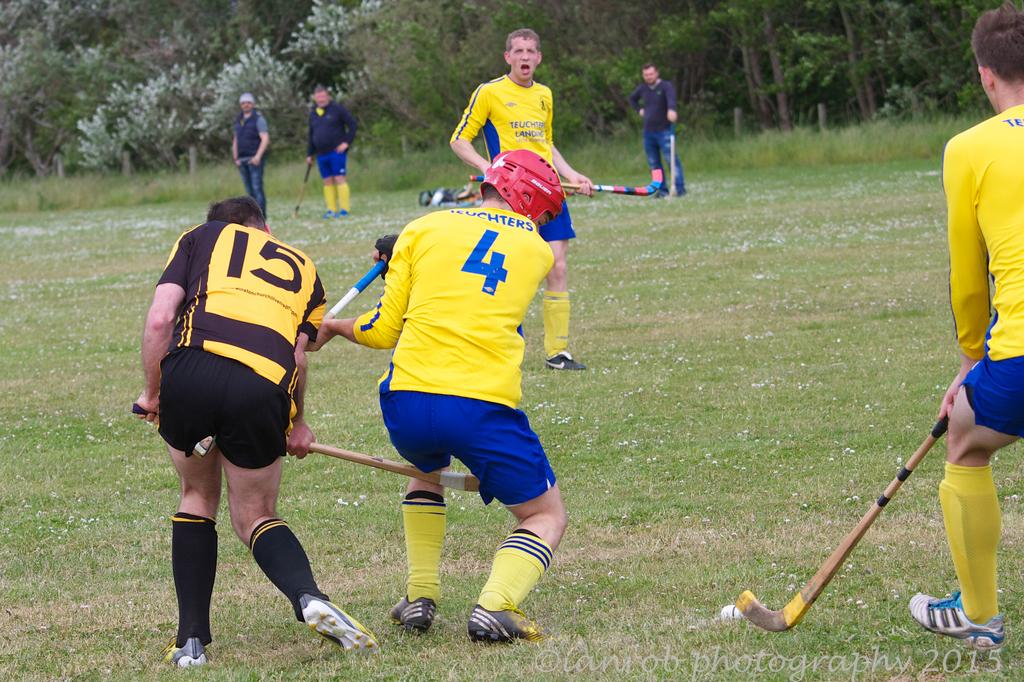What is the number of the player that has black shorts on?
Ensure brevity in your answer.  15. What is the number of the player in the red helmet?
Your response must be concise. 4. 